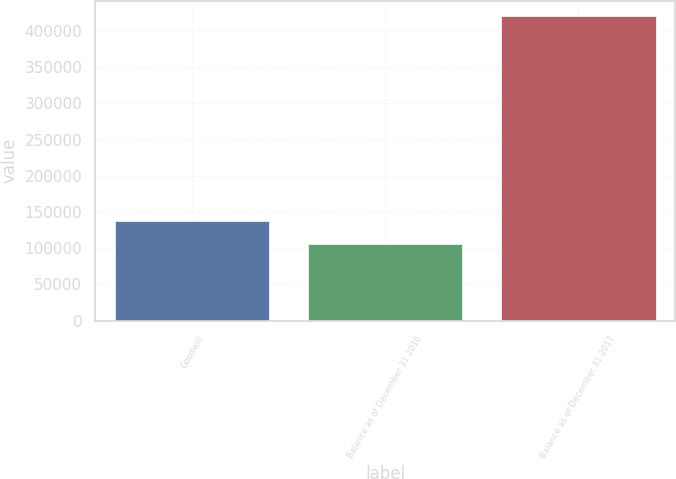<chart> <loc_0><loc_0><loc_500><loc_500><bar_chart><fcel>Goodwill<fcel>Balance as of December 31 2016<fcel>Balance as of December 31 2017<nl><fcel>137394<fcel>105900<fcel>420842<nl></chart> 